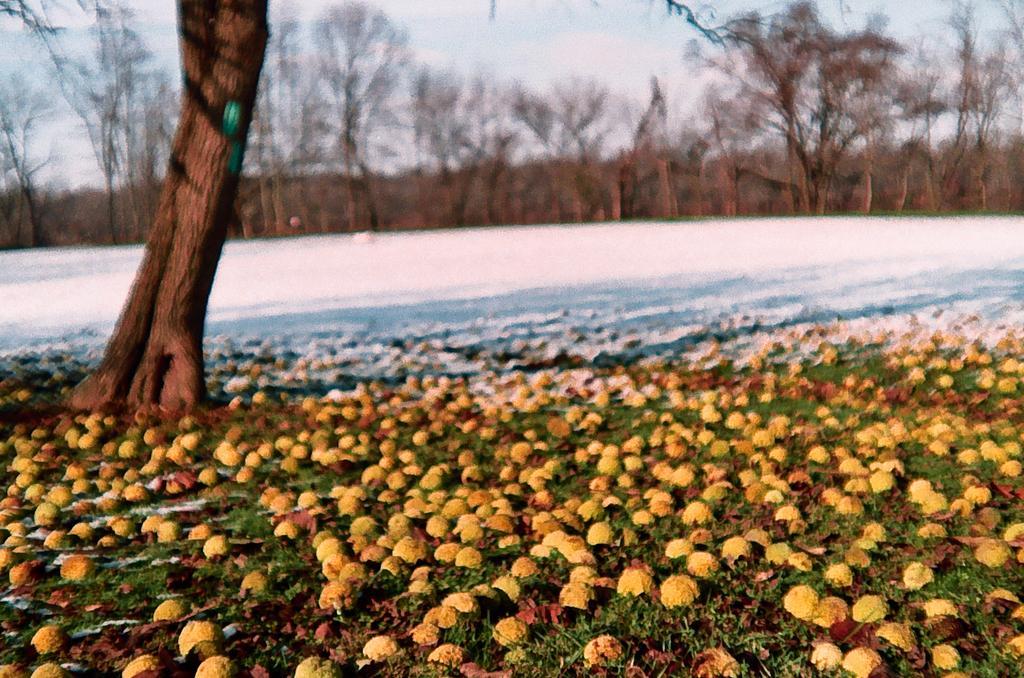Can you describe this image briefly? In the image I can see some fruits on the ground and also I can see snow and some trees and plants around. 